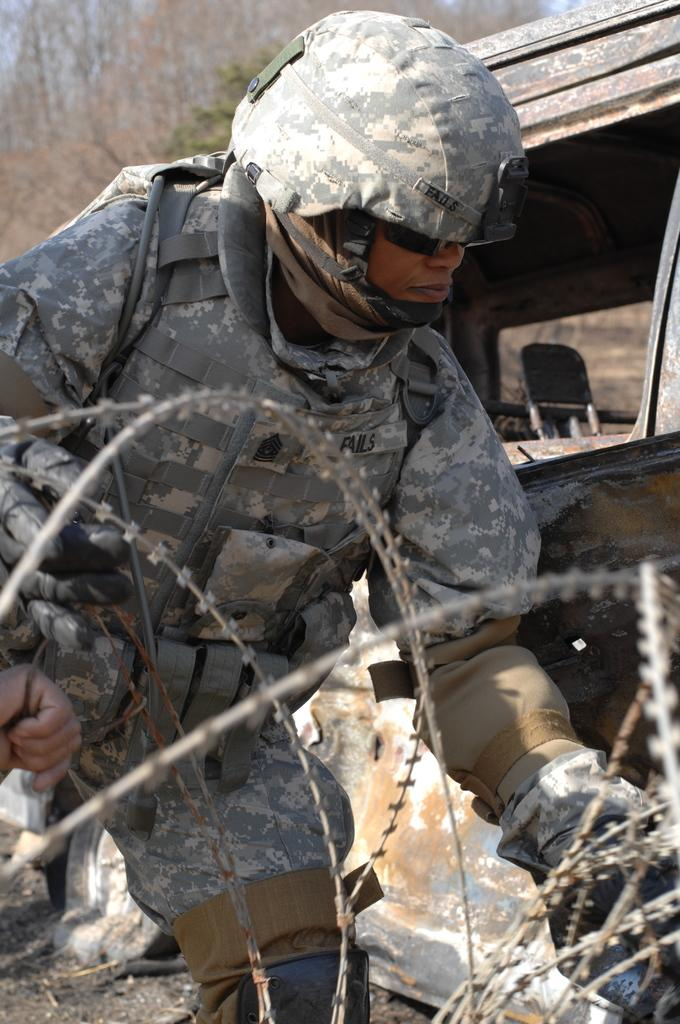What is the person in the image wearing on their head? The person in the image is wearing a helmet. What type of barrier can be seen in the image? There is a barbed fence in the image. What type of transportation is present in the image? There is a vehicle in the image. What can be seen in the background of the image? Trees and the sky are visible in the background of the image. What type of flowers are growing near the person's toes in the image? There are no flowers or reference to toes in the image; it features a person wearing a helmet, a barbed fence, a vehicle, and a background with trees and the sky. 